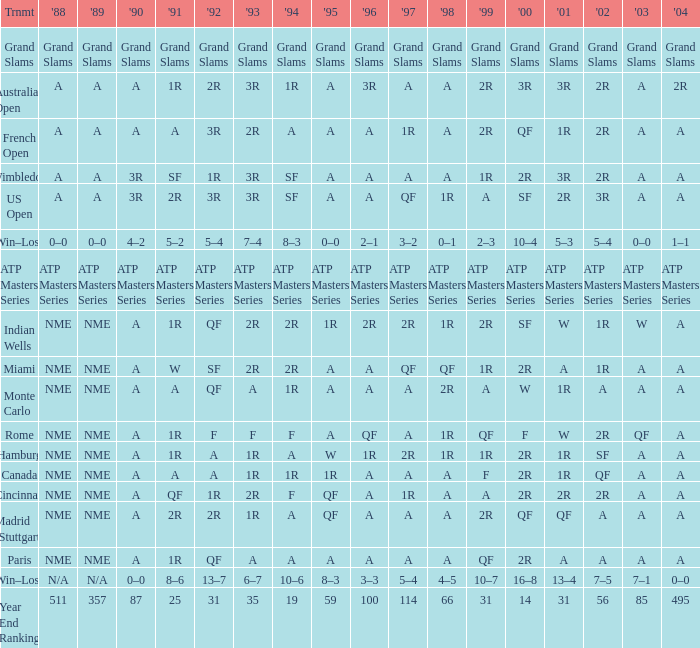What shows for 2002 when the 1991 is w? 1R. 